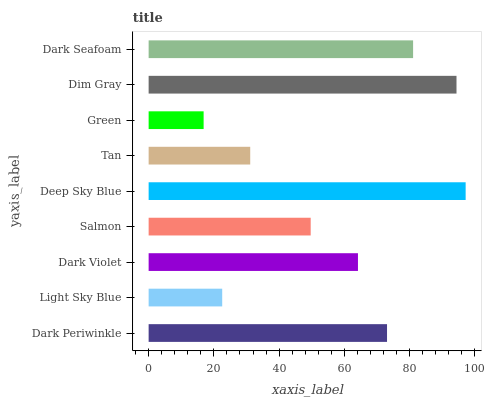Is Green the minimum?
Answer yes or no. Yes. Is Deep Sky Blue the maximum?
Answer yes or no. Yes. Is Light Sky Blue the minimum?
Answer yes or no. No. Is Light Sky Blue the maximum?
Answer yes or no. No. Is Dark Periwinkle greater than Light Sky Blue?
Answer yes or no. Yes. Is Light Sky Blue less than Dark Periwinkle?
Answer yes or no. Yes. Is Light Sky Blue greater than Dark Periwinkle?
Answer yes or no. No. Is Dark Periwinkle less than Light Sky Blue?
Answer yes or no. No. Is Dark Violet the high median?
Answer yes or no. Yes. Is Dark Violet the low median?
Answer yes or no. Yes. Is Dark Periwinkle the high median?
Answer yes or no. No. Is Deep Sky Blue the low median?
Answer yes or no. No. 